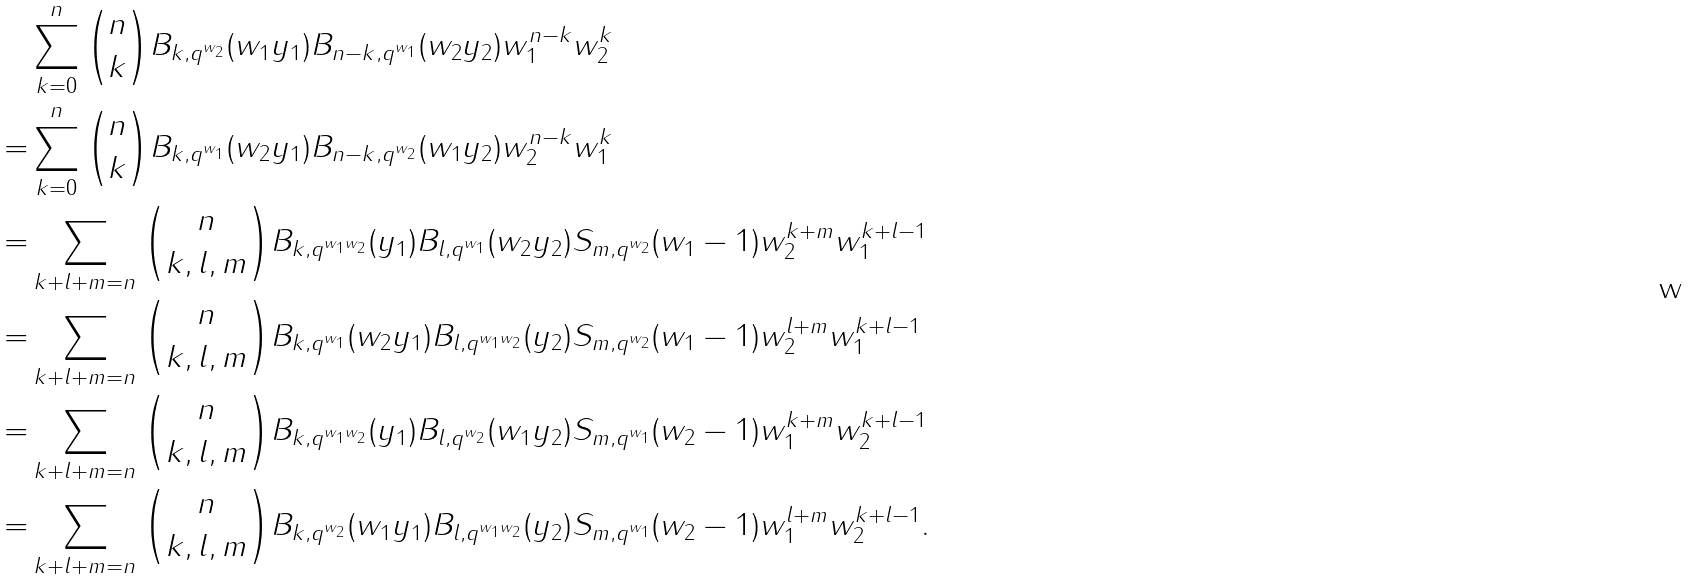Convert formula to latex. <formula><loc_0><loc_0><loc_500><loc_500>& \sum _ { k = 0 } ^ { n } \binom { n } { k } B _ { k , q ^ { w _ { 2 } } } ( w _ { 1 } y _ { 1 } ) B _ { n - k , q ^ { w _ { 1 } } } ( w _ { 2 } y _ { 2 } ) w _ { 1 } ^ { n - k } w _ { 2 } ^ { k } \\ = & \sum _ { k = 0 } ^ { n } \binom { n } { k } B _ { k , q ^ { w _ { 1 } } } ( w _ { 2 } y _ { 1 } ) B _ { n - k , q ^ { w _ { 2 } } } ( w _ { 1 } y _ { 2 } ) w _ { 2 } ^ { n - k } w _ { 1 } ^ { k } \\ = & \sum _ { k + l + m = n } \binom { n } { k , l , m } B _ { k , q ^ { w _ { 1 } w _ { 2 } } } ( y _ { 1 } ) B _ { l , q ^ { w _ { 1 } } } ( w _ { 2 } y _ { 2 } ) S _ { m , q ^ { w _ { 2 } } } ( w _ { 1 } - 1 ) w _ { 2 } ^ { k + m } w _ { 1 } ^ { k + l - 1 } \\ = & \sum _ { k + l + m = n } \binom { n } { k , l , m } B _ { k , q ^ { w _ { 1 } } } ( w _ { 2 } y _ { 1 } ) B _ { l , q ^ { w _ { 1 } w _ { 2 } } } ( y _ { 2 } ) S _ { m , q ^ { w _ { 2 } } } ( w _ { 1 } - 1 ) w _ { 2 } ^ { l + m } w _ { 1 } ^ { k + l - 1 } \\ = & \sum _ { k + l + m = n } \binom { n } { k , l , m } B _ { k , q ^ { w _ { 1 } w _ { 2 } } } ( y _ { 1 } ) B _ { l , q ^ { w _ { 2 } } } ( w _ { 1 } y _ { 2 } ) S _ { m , q ^ { w _ { 1 } } } ( w _ { 2 } - 1 ) w _ { 1 } ^ { k + m } w _ { 2 } ^ { k + l - 1 } \\ = & \sum _ { k + l + m = n } \binom { n } { k , l , m } B _ { k , q ^ { w _ { 2 } } } ( w _ { 1 } y _ { 1 } ) B _ { l , q ^ { w _ { 1 } w _ { 2 } } } ( y _ { 2 } ) S _ { m , q ^ { w _ { 1 } } } ( w _ { 2 } - 1 ) w _ { 1 } ^ { l + m } w _ { 2 } ^ { k + l - 1 } .</formula> 